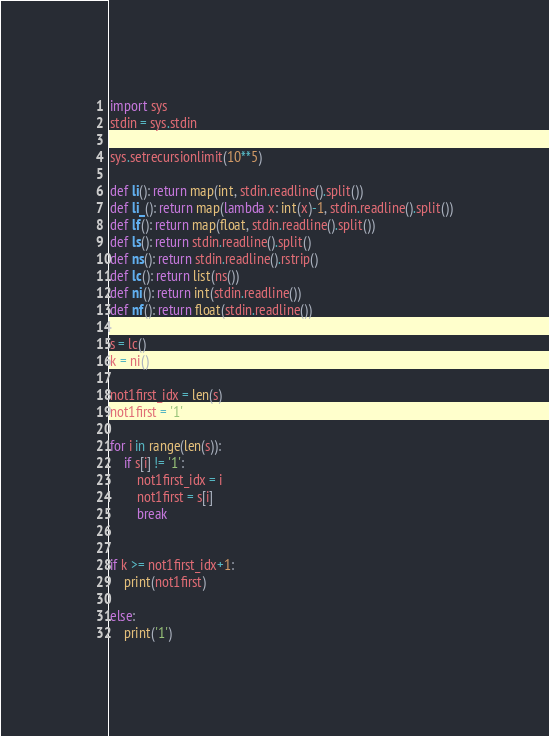Convert code to text. <code><loc_0><loc_0><loc_500><loc_500><_Python_>import sys
stdin = sys.stdin

sys.setrecursionlimit(10**5)

def li(): return map(int, stdin.readline().split())
def li_(): return map(lambda x: int(x)-1, stdin.readline().split())
def lf(): return map(float, stdin.readline().split())
def ls(): return stdin.readline().split()
def ns(): return stdin.readline().rstrip()
def lc(): return list(ns())
def ni(): return int(stdin.readline())
def nf(): return float(stdin.readline())

s = lc()
k = ni()

not1first_idx = len(s)
not1first = '1'

for i in range(len(s)):
    if s[i] != '1':
        not1first_idx = i
        not1first = s[i]
        break
        
        
if k >= not1first_idx+1:
    print(not1first)
    
else:
    print('1')</code> 